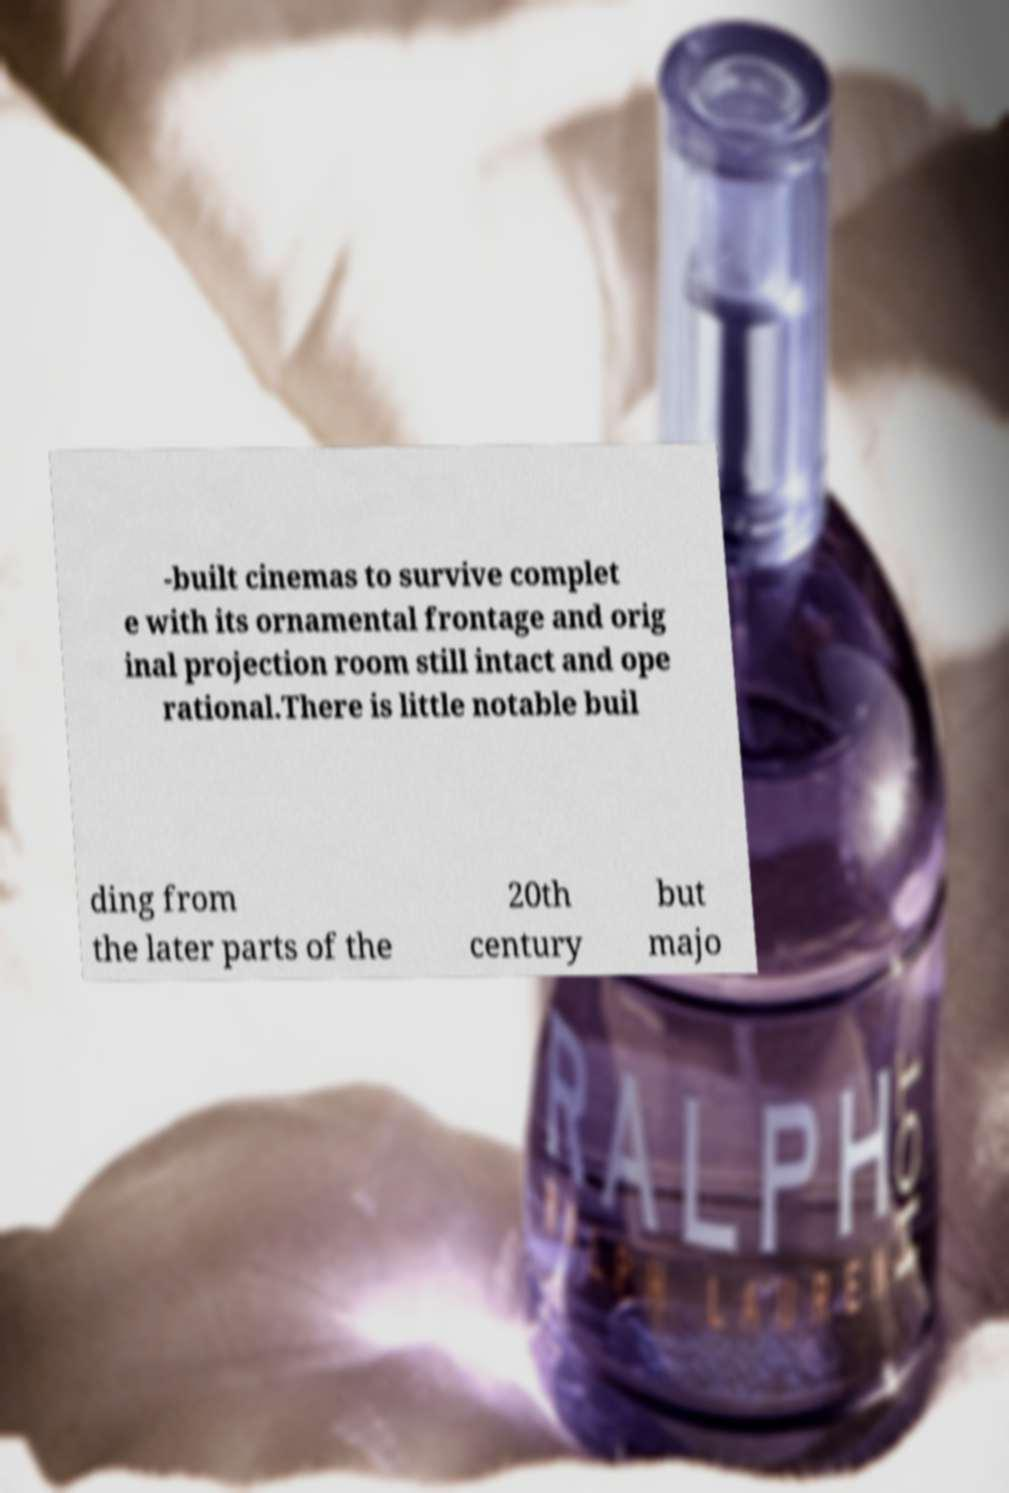Could you assist in decoding the text presented in this image and type it out clearly? -built cinemas to survive complet e with its ornamental frontage and orig inal projection room still intact and ope rational.There is little notable buil ding from the later parts of the 20th century but majo 